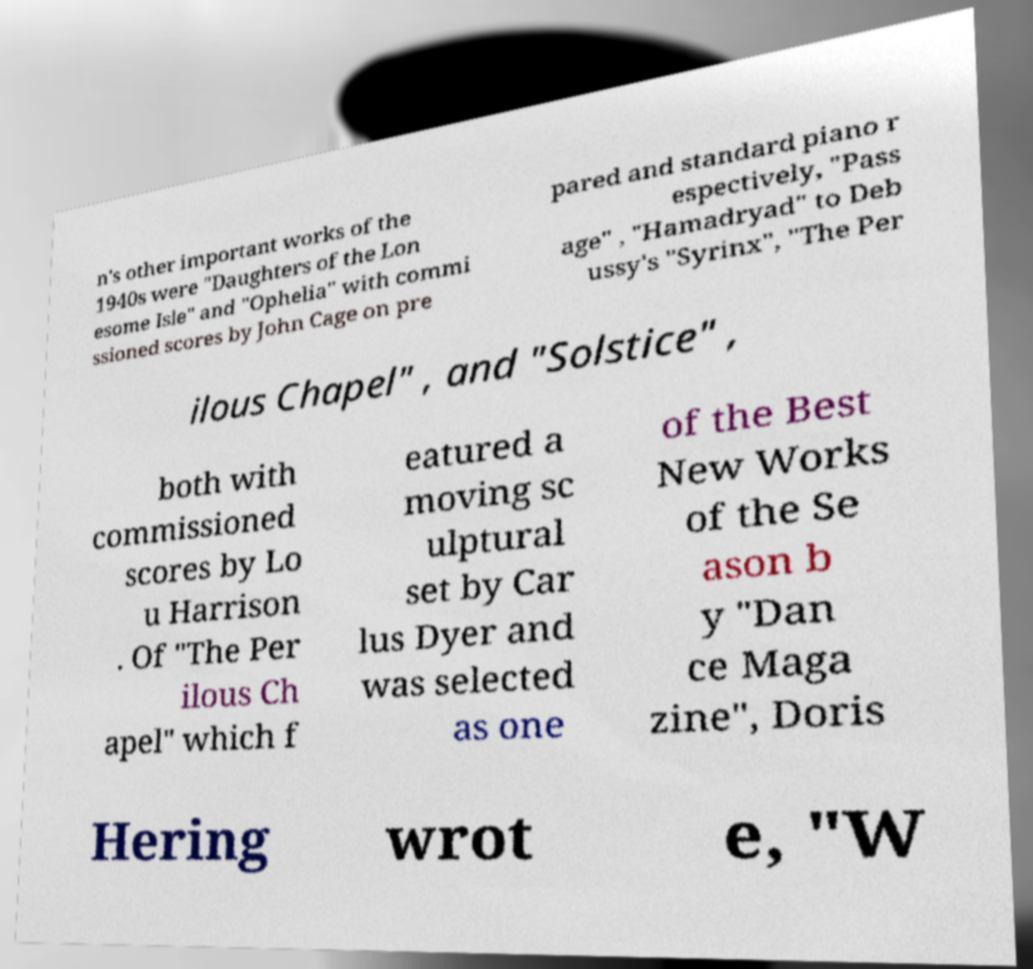Could you assist in decoding the text presented in this image and type it out clearly? n's other important works of the 1940s were "Daughters of the Lon esome Isle" and "Ophelia" with commi ssioned scores by John Cage on pre pared and standard piano r espectively, "Pass age" , "Hamadryad" to Deb ussy's "Syrinx", "The Per ilous Chapel" , and "Solstice" , both with commissioned scores by Lo u Harrison . Of "The Per ilous Ch apel" which f eatured a moving sc ulptural set by Car lus Dyer and was selected as one of the Best New Works of the Se ason b y "Dan ce Maga zine", Doris Hering wrot e, "W 